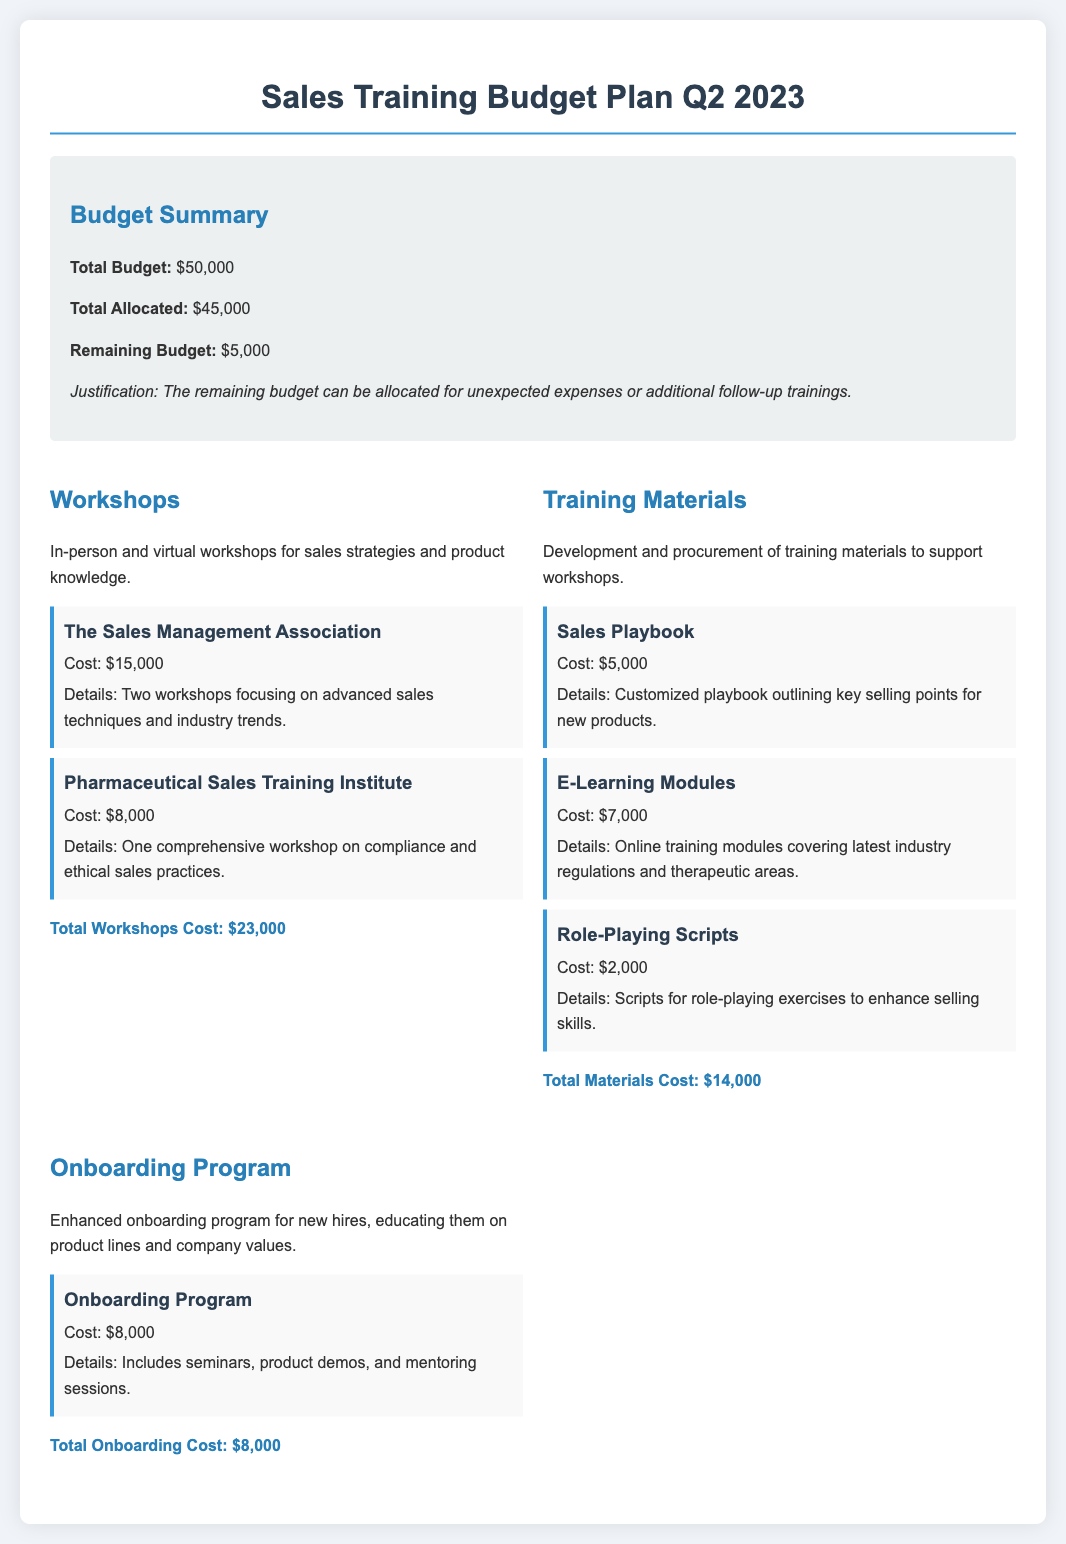What is the total budget? The total budget is presented in the budget summary section of the document.
Answer: $50,000 What is the cost of the workshop by The Sales Management Association? This cost is specified under the workshop details.
Answer: $15,000 What is the total allocated budget? The total allocated budget is specified in the budget summary section.
Answer: $45,000 How much is allocated for the Sales Playbook? The allocated amount for the Sales Playbook is mentioned in the training materials section.
Answer: $5,000 What is the remaining budget after allocations? The remaining budget is calculated as the total budget minus the total allocated budget.
Answer: $5,000 How much is being spent on onboarding programs? The cost allocated for the onboarding program is detailed in the onboarding program section.
Answer: $8,000 What is the total materials cost? This total is provided in the training materials section, summarizing the costs for each item listed.
Answer: $14,000 How many workshops are mentioned in the document? This number is derived from the workshop details provided in the budget.
Answer: Two What is included in the onboarding program? This is outlined in the details of the onboarding program section.
Answer: Seminars, product demos, and mentoring sessions 